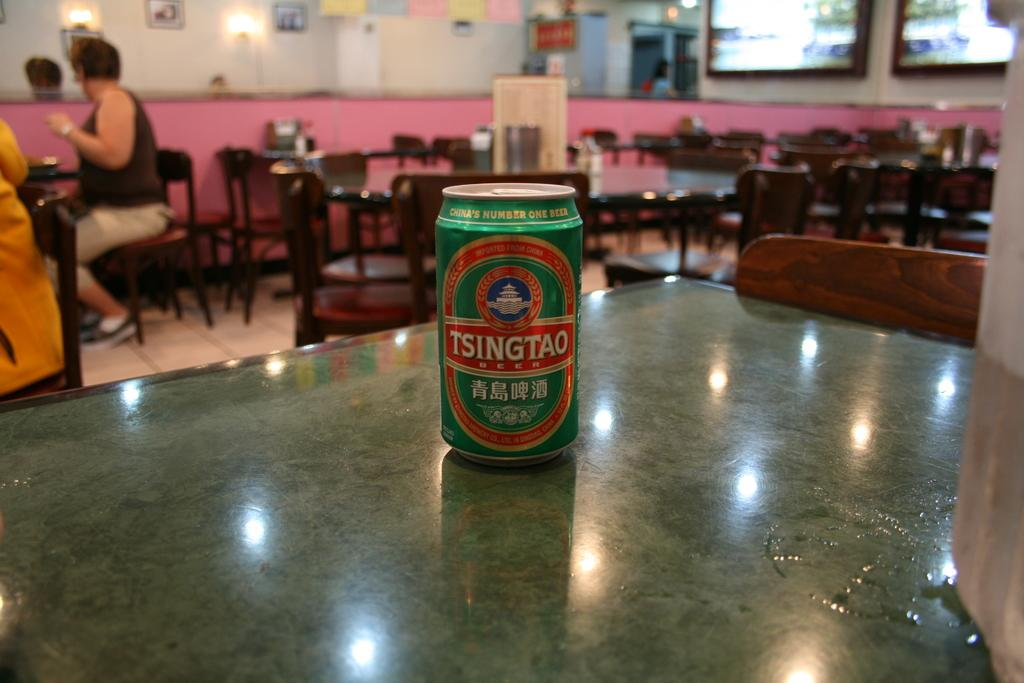Provide a one-sentence caption for the provided image. A can of Tsingtao beer sits unopened on a table. 